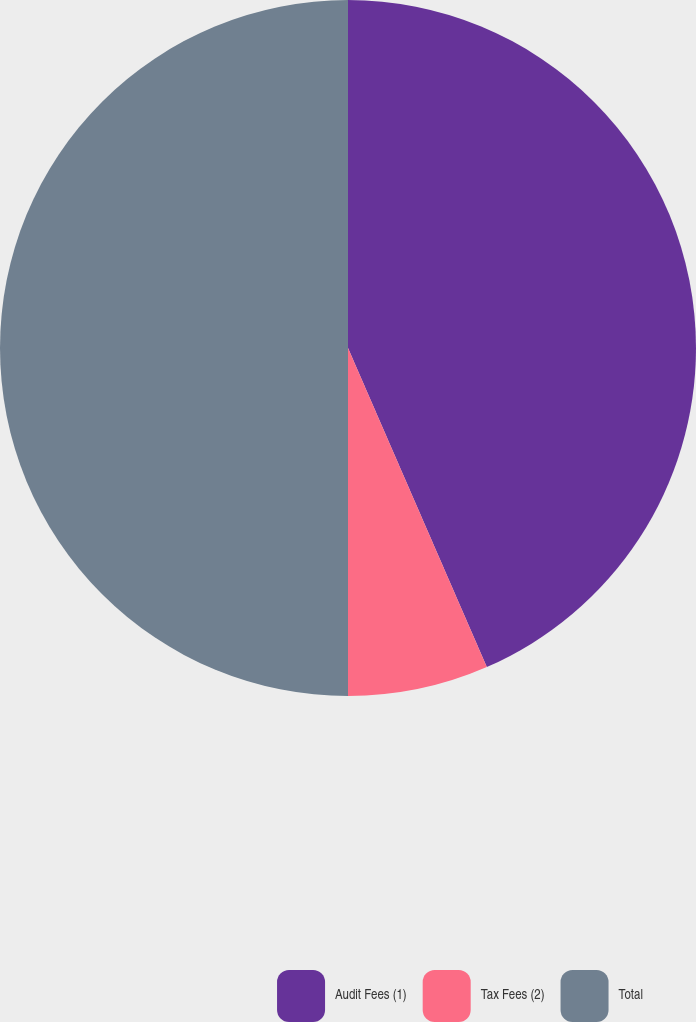Convert chart. <chart><loc_0><loc_0><loc_500><loc_500><pie_chart><fcel>Audit Fees (1)<fcel>Tax Fees (2)<fcel>Total<nl><fcel>43.47%<fcel>6.53%<fcel>50.0%<nl></chart> 